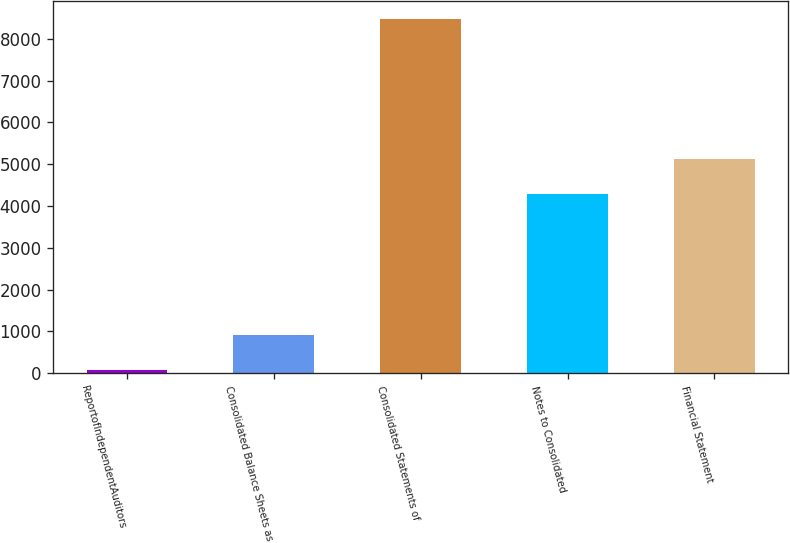Convert chart. <chart><loc_0><loc_0><loc_500><loc_500><bar_chart><fcel>ReportofIndependentAuditors<fcel>Consolidated Balance Sheets as<fcel>Consolidated Statements of<fcel>Notes to Consolidated<fcel>Financial Statement<nl><fcel>79<fcel>919.6<fcel>8485<fcel>4282<fcel>5122.6<nl></chart> 